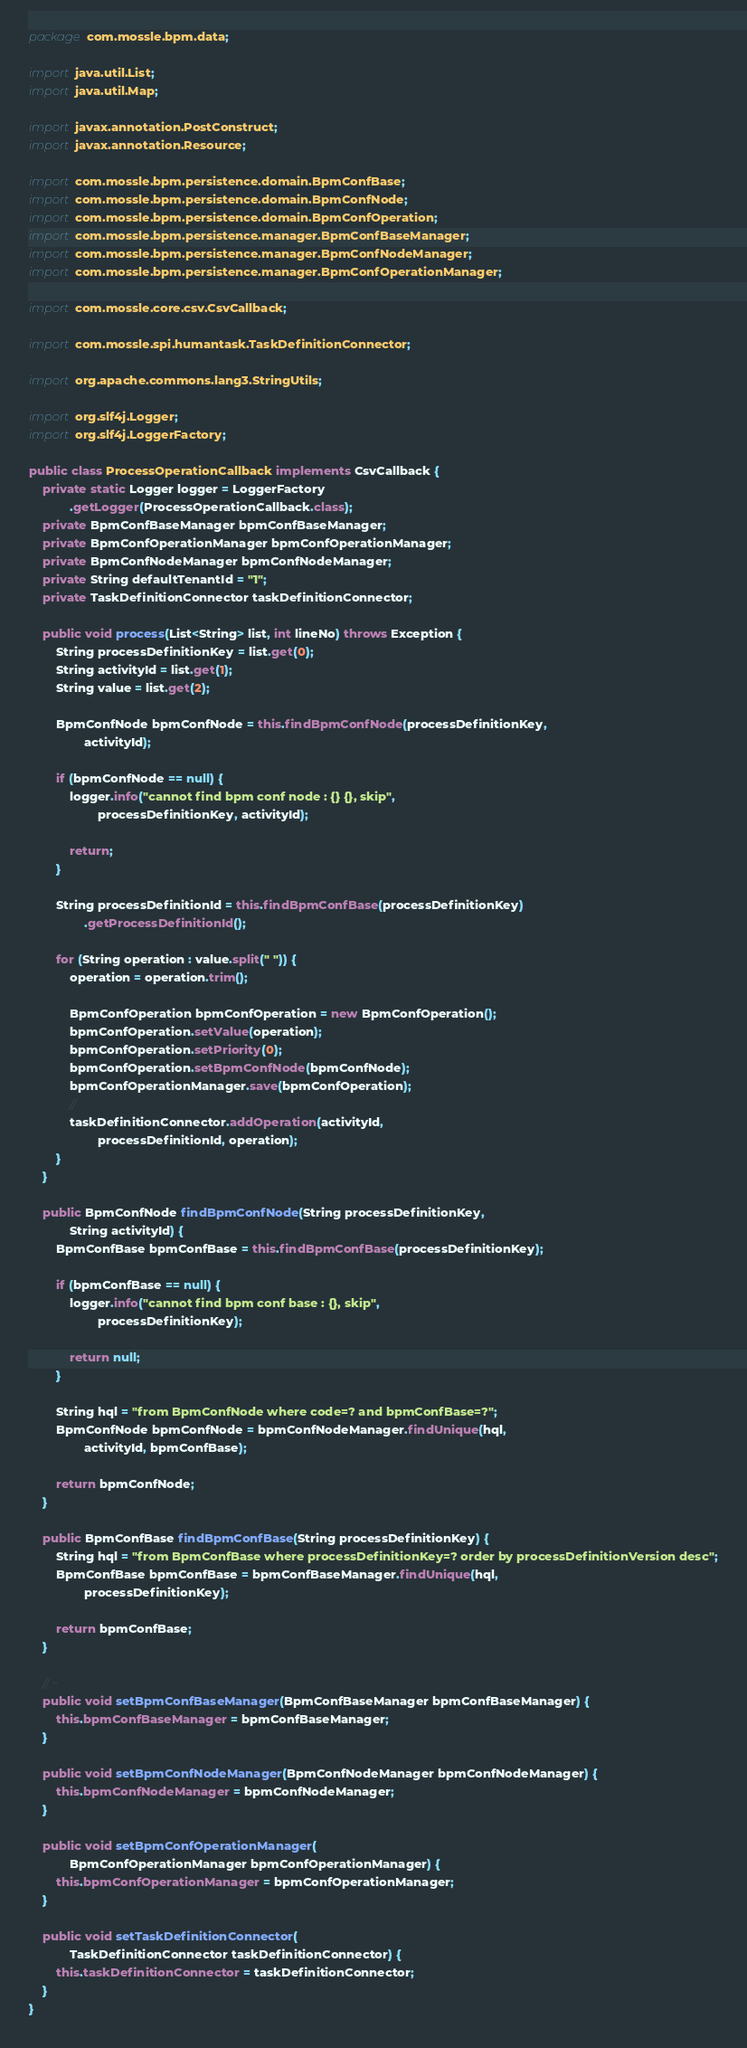Convert code to text. <code><loc_0><loc_0><loc_500><loc_500><_Java_>package com.mossle.bpm.data;

import java.util.List;
import java.util.Map;

import javax.annotation.PostConstruct;
import javax.annotation.Resource;

import com.mossle.bpm.persistence.domain.BpmConfBase;
import com.mossle.bpm.persistence.domain.BpmConfNode;
import com.mossle.bpm.persistence.domain.BpmConfOperation;
import com.mossle.bpm.persistence.manager.BpmConfBaseManager;
import com.mossle.bpm.persistence.manager.BpmConfNodeManager;
import com.mossle.bpm.persistence.manager.BpmConfOperationManager;

import com.mossle.core.csv.CsvCallback;

import com.mossle.spi.humantask.TaskDefinitionConnector;

import org.apache.commons.lang3.StringUtils;

import org.slf4j.Logger;
import org.slf4j.LoggerFactory;

public class ProcessOperationCallback implements CsvCallback {
    private static Logger logger = LoggerFactory
            .getLogger(ProcessOperationCallback.class);
    private BpmConfBaseManager bpmConfBaseManager;
    private BpmConfOperationManager bpmConfOperationManager;
    private BpmConfNodeManager bpmConfNodeManager;
    private String defaultTenantId = "1";
    private TaskDefinitionConnector taskDefinitionConnector;

    public void process(List<String> list, int lineNo) throws Exception {
        String processDefinitionKey = list.get(0);
        String activityId = list.get(1);
        String value = list.get(2);

        BpmConfNode bpmConfNode = this.findBpmConfNode(processDefinitionKey,
                activityId);

        if (bpmConfNode == null) {
            logger.info("cannot find bpm conf node : {} {}, skip",
                    processDefinitionKey, activityId);

            return;
        }

        String processDefinitionId = this.findBpmConfBase(processDefinitionKey)
                .getProcessDefinitionId();

        for (String operation : value.split(" ")) {
            operation = operation.trim();

            BpmConfOperation bpmConfOperation = new BpmConfOperation();
            bpmConfOperation.setValue(operation);
            bpmConfOperation.setPriority(0);
            bpmConfOperation.setBpmConfNode(bpmConfNode);
            bpmConfOperationManager.save(bpmConfOperation);
            //
            taskDefinitionConnector.addOperation(activityId,
                    processDefinitionId, operation);
        }
    }

    public BpmConfNode findBpmConfNode(String processDefinitionKey,
            String activityId) {
        BpmConfBase bpmConfBase = this.findBpmConfBase(processDefinitionKey);

        if (bpmConfBase == null) {
            logger.info("cannot find bpm conf base : {}, skip",
                    processDefinitionKey);

            return null;
        }

        String hql = "from BpmConfNode where code=? and bpmConfBase=?";
        BpmConfNode bpmConfNode = bpmConfNodeManager.findUnique(hql,
                activityId, bpmConfBase);

        return bpmConfNode;
    }

    public BpmConfBase findBpmConfBase(String processDefinitionKey) {
        String hql = "from BpmConfBase where processDefinitionKey=? order by processDefinitionVersion desc";
        BpmConfBase bpmConfBase = bpmConfBaseManager.findUnique(hql,
                processDefinitionKey);

        return bpmConfBase;
    }

    // ~
    public void setBpmConfBaseManager(BpmConfBaseManager bpmConfBaseManager) {
        this.bpmConfBaseManager = bpmConfBaseManager;
    }

    public void setBpmConfNodeManager(BpmConfNodeManager bpmConfNodeManager) {
        this.bpmConfNodeManager = bpmConfNodeManager;
    }

    public void setBpmConfOperationManager(
            BpmConfOperationManager bpmConfOperationManager) {
        this.bpmConfOperationManager = bpmConfOperationManager;
    }

    public void setTaskDefinitionConnector(
            TaskDefinitionConnector taskDefinitionConnector) {
        this.taskDefinitionConnector = taskDefinitionConnector;
    }
}
</code> 